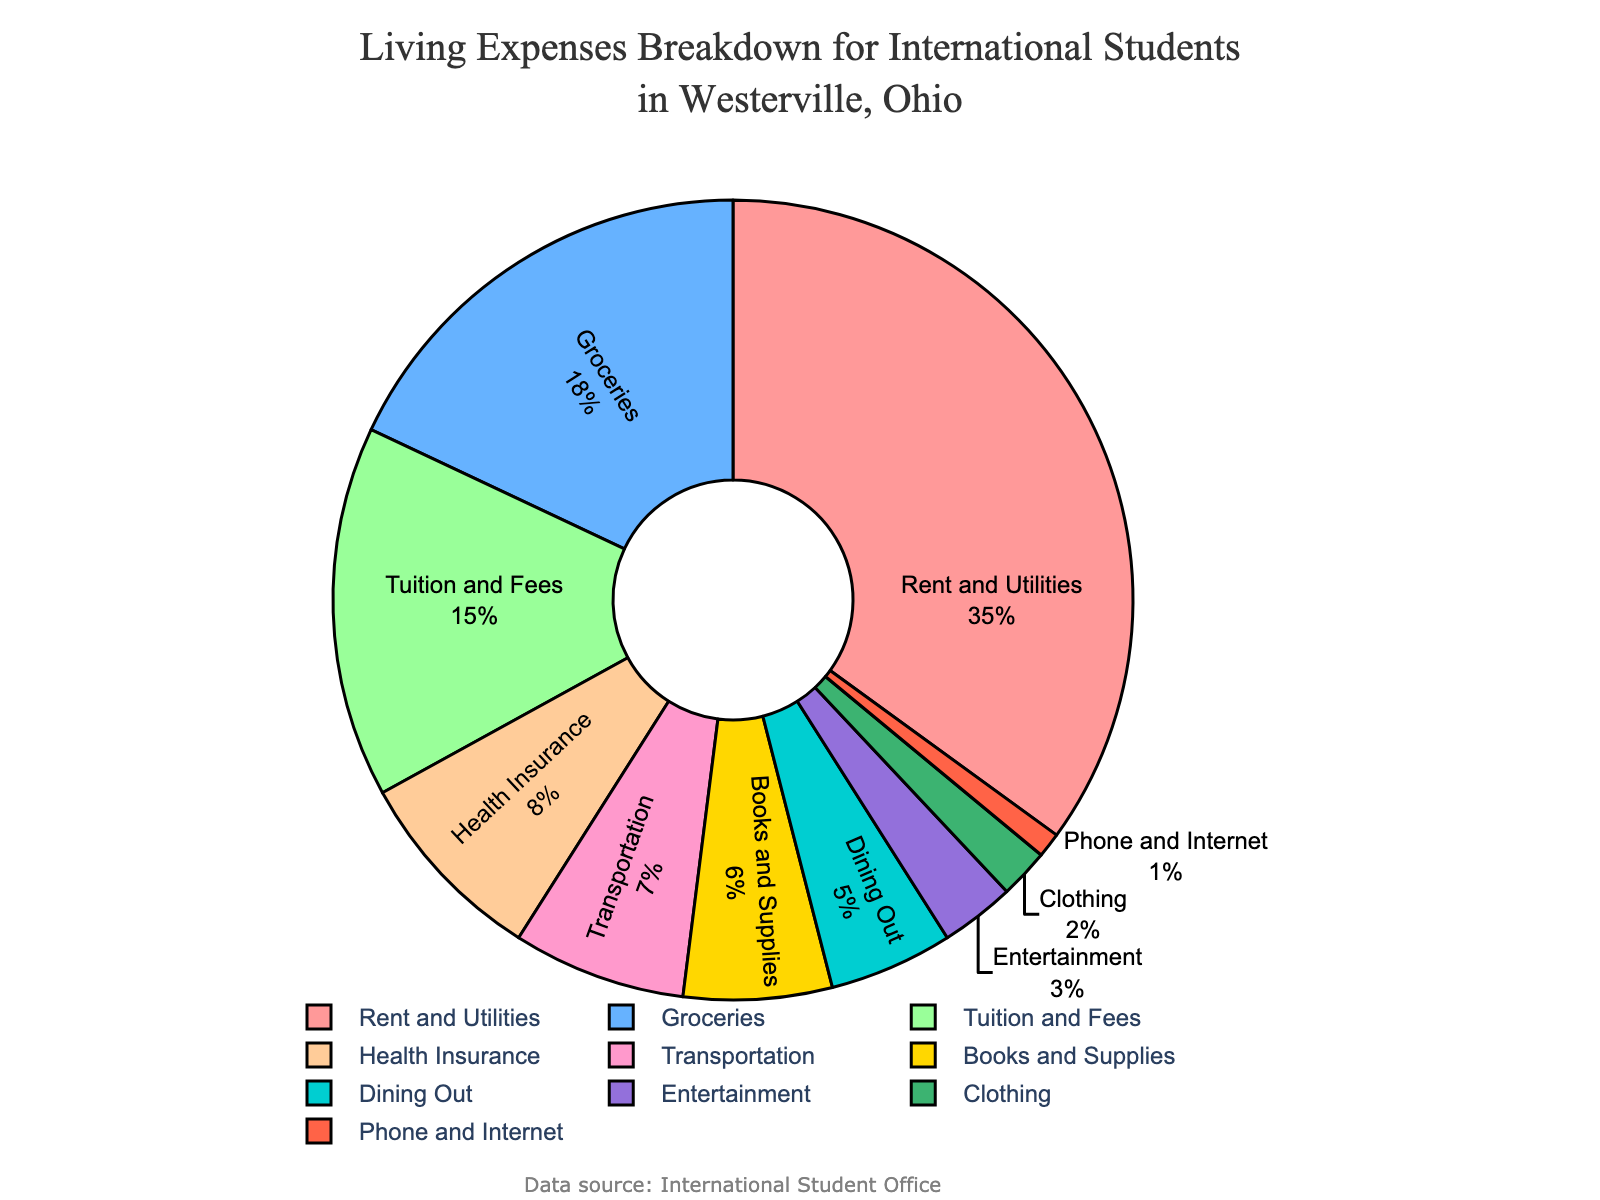What percentage of the living expenses are spent on Rent and Utilities? Rent and Utilities make up 35% of the living expenses as indicated by the label on the pie chart.
Answer: 35% What are the two categories with the largest percentage of living expenses? The pie chart shows Rent and Utilities at 35% and Groceries at 18%, which are the largest percentages among all categories.
Answer: Rent and Utilities and Groceries How much more is spent on Dining Out compared to Entertainment? Dining Out represents 5% of living expenses, while Entertainment represents 3%. The difference is 5% - 3% = 2%.
Answer: 2% Which category comprises a smaller percentage of living expenses compared to Health Insurance but more than Transportation? Health Insurance accounts for 8%, and Transportation accounts for 7%. Books and Supplies are at 6%, which fits between these percentages.
Answer: Books and Supplies What combined percentage of living expenses is allocated to Groceries, Tuition and Fees, and Transportation? Groceries account for 18%, Tuition and Fees for 15%, and Transportation for 7%. The sum of these percentages is 18% + 15% + 7% = 40%.
Answer: 40% Which category has the smallest percentage of living expenses? The smallest percentage of living expenses is allocated to Phone and Internet at 1% as shown on the pie chart.
Answer: Phone and Internet How does the percentage spent on Groceries compare to that spent on Tuition and Fees? The pie chart shows Groceries at 18% and Tuition and Fees at 15%. Groceries have a higher percentage compared to Tuition and Fees.
Answer: Groceries have a higher percentage What is the total percentage of living expenses spent on Health Insurance and Clothing combined? Health Insurance is 8%, and Clothing is 2%. Adding these together gives 8% + 2% = 10%.
Answer: 10% Are more living expenses spent on Entertainment or Clothing? The pie chart shows that Entertainment is at 3% and Clothing is at 2%. Entertainment has a higher percentage of living expenses compared to Clothing.
Answer: Entertainment What category on the pie chart is represented by a yellow slice? The yellow slice represents Health Insurance, which accounts for 8% of the living expenses.
Answer: Health Insurance 